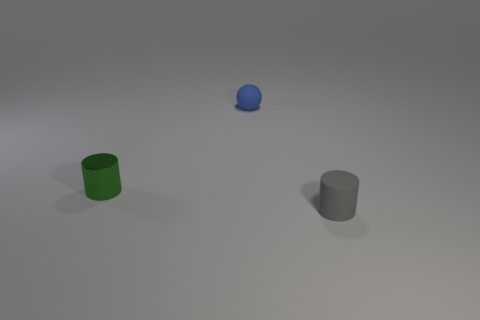Add 2 matte balls. How many objects exist? 5 Subtract all balls. How many objects are left? 2 Add 3 rubber objects. How many rubber objects are left? 5 Add 3 balls. How many balls exist? 4 Subtract 0 purple blocks. How many objects are left? 3 Subtract all tiny brown rubber spheres. Subtract all small metal cylinders. How many objects are left? 2 